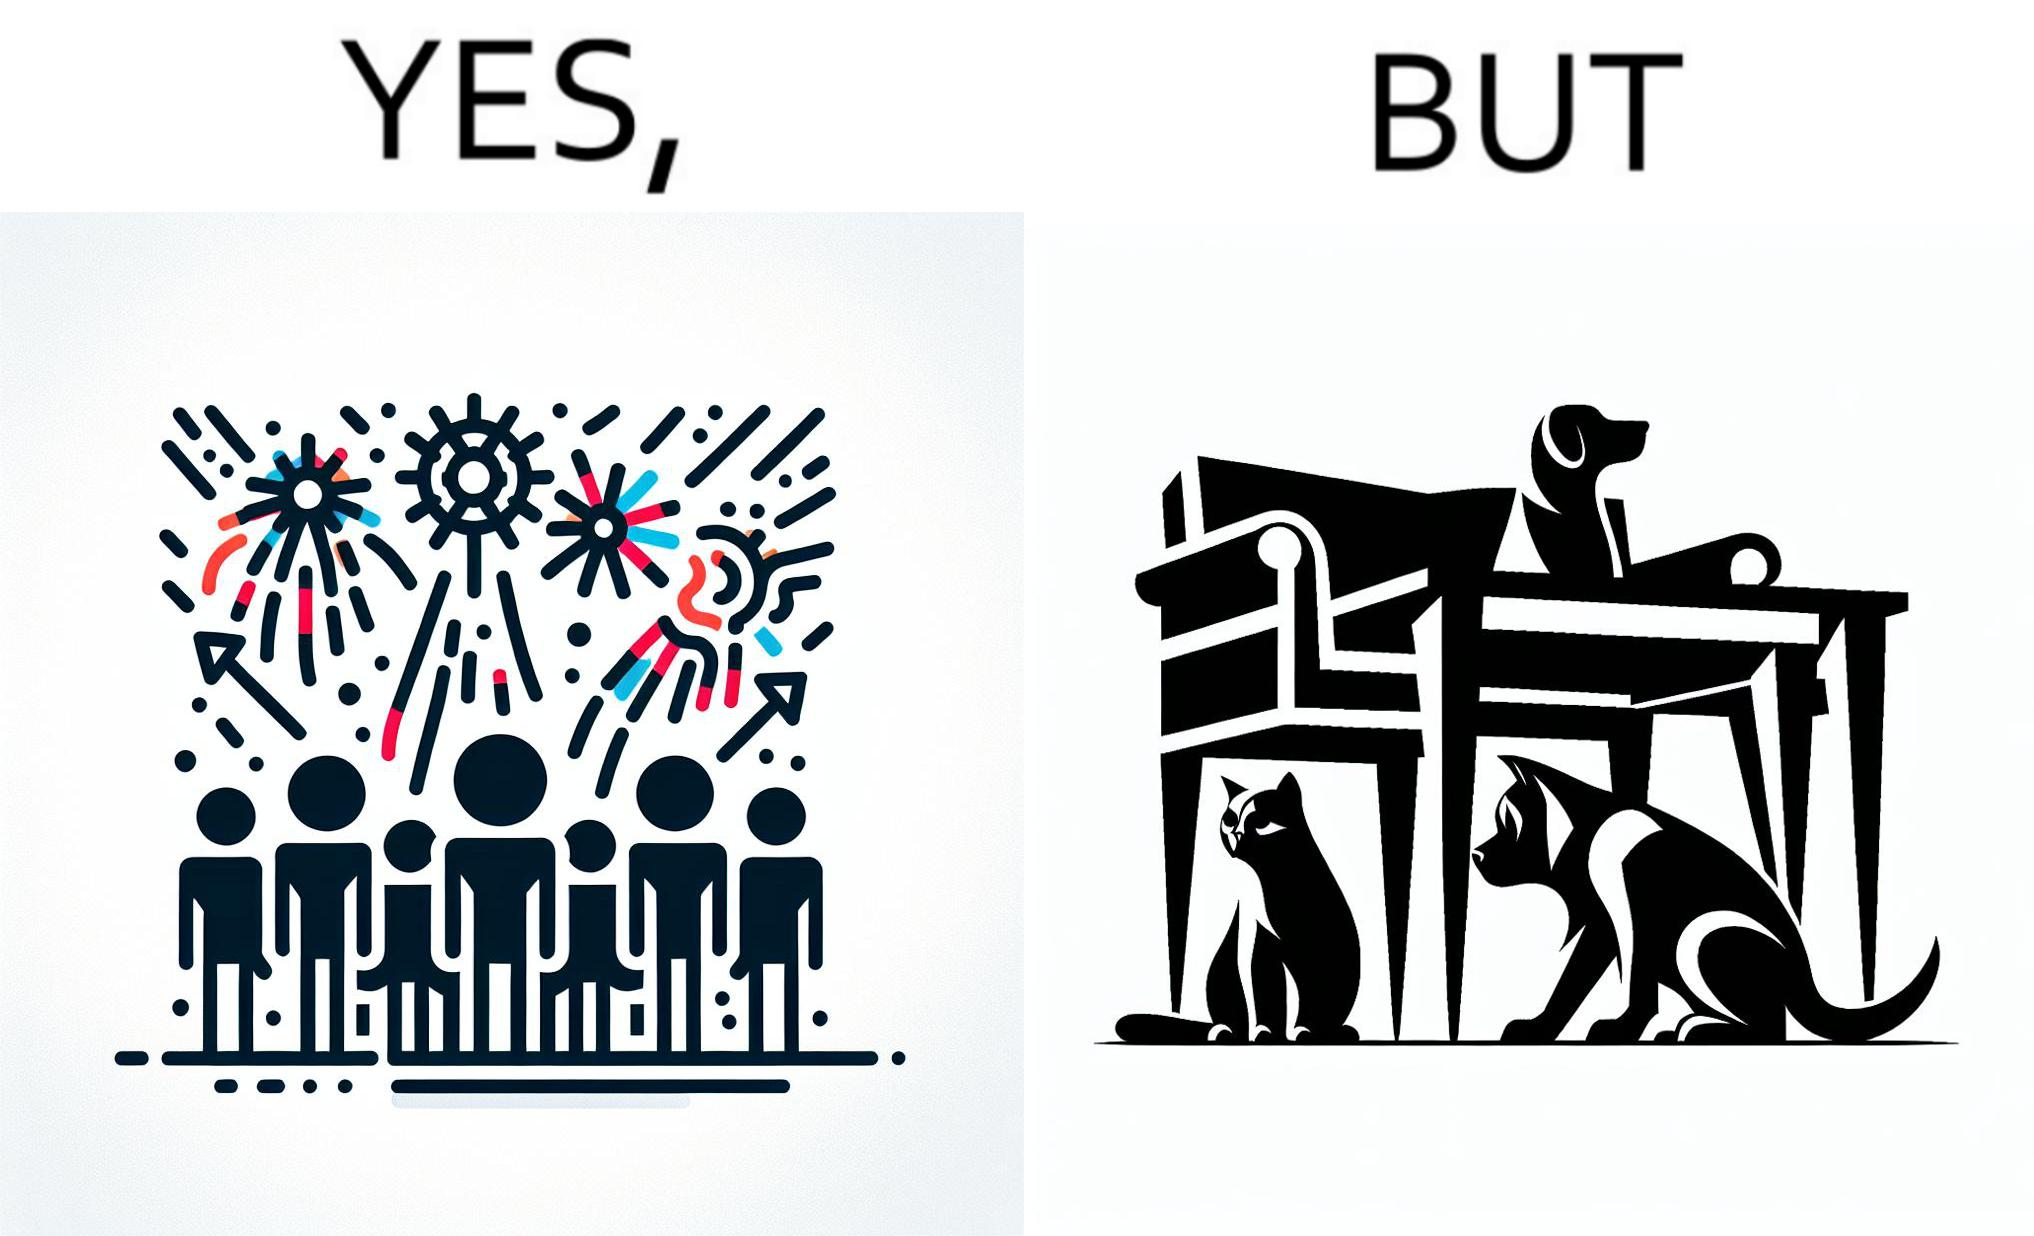Explain why this image is satirical. The image is satirical because while firecrackers in the sky look pretty, not everyone likes them. Animals are very scared of the firecrackers. 